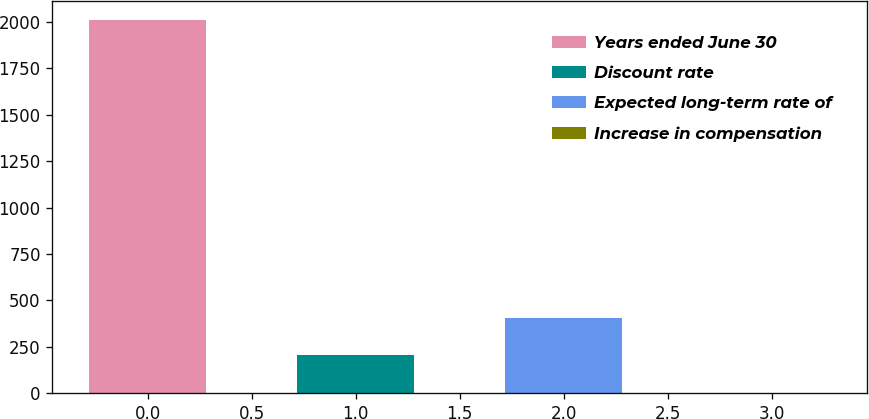Convert chart. <chart><loc_0><loc_0><loc_500><loc_500><bar_chart><fcel>Years ended June 30<fcel>Discount rate<fcel>Expected long-term rate of<fcel>Increase in compensation<nl><fcel>2012<fcel>204.8<fcel>405.6<fcel>4<nl></chart> 